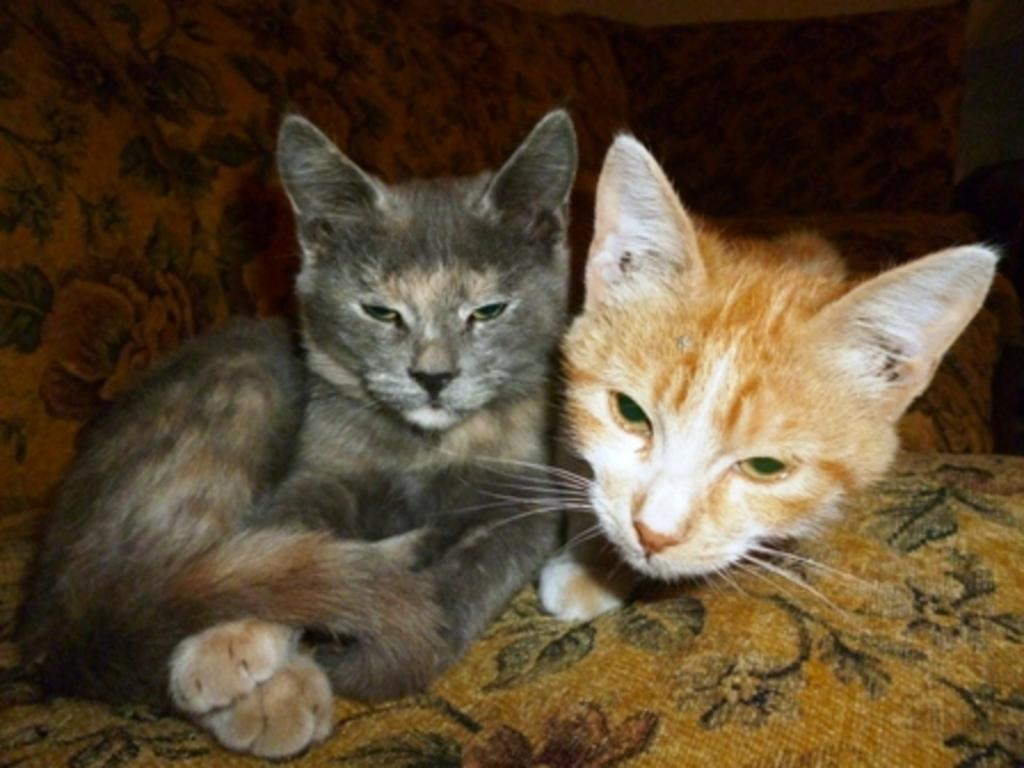How many cats are in the image? There are two cats in the image. Where are the cats located in the image? The cats are in the center of the image. What are the cats sitting on in the image? The cats are on a couch. What type of jam do the girls in the image prefer? There are no girls present in the image, only two cats. 